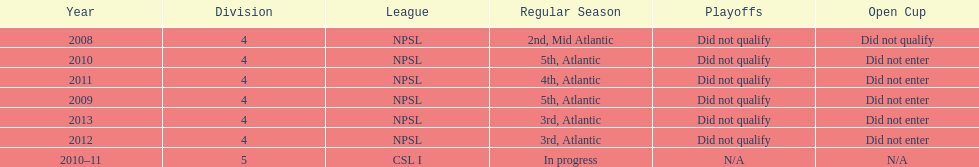How did they place the year after they were 4th in the regular season? 3rd. 